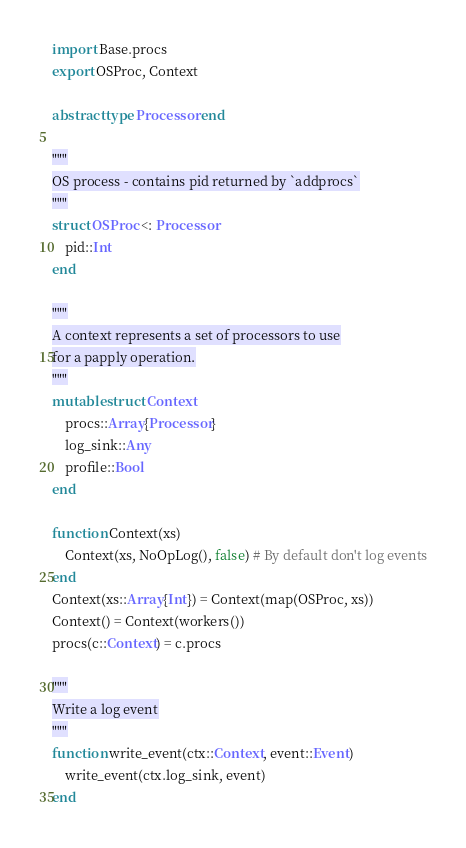<code> <loc_0><loc_0><loc_500><loc_500><_Julia_>import Base.procs
export OSProc, Context

abstract type Processor end

"""
OS process - contains pid returned by `addprocs`
"""
struct OSProc <: Processor
    pid::Int
end

"""
A context represents a set of processors to use
for a papply operation.
"""
mutable struct Context
    procs::Array{Processor}
    log_sink::Any
    profile::Bool
end

function Context(xs)
    Context(xs, NoOpLog(), false) # By default don't log events
end
Context(xs::Array{Int}) = Context(map(OSProc, xs))
Context() = Context(workers())
procs(c::Context) = c.procs

"""
Write a log event
"""
function write_event(ctx::Context, event::Event)
    write_event(ctx.log_sink, event)
end
</code> 